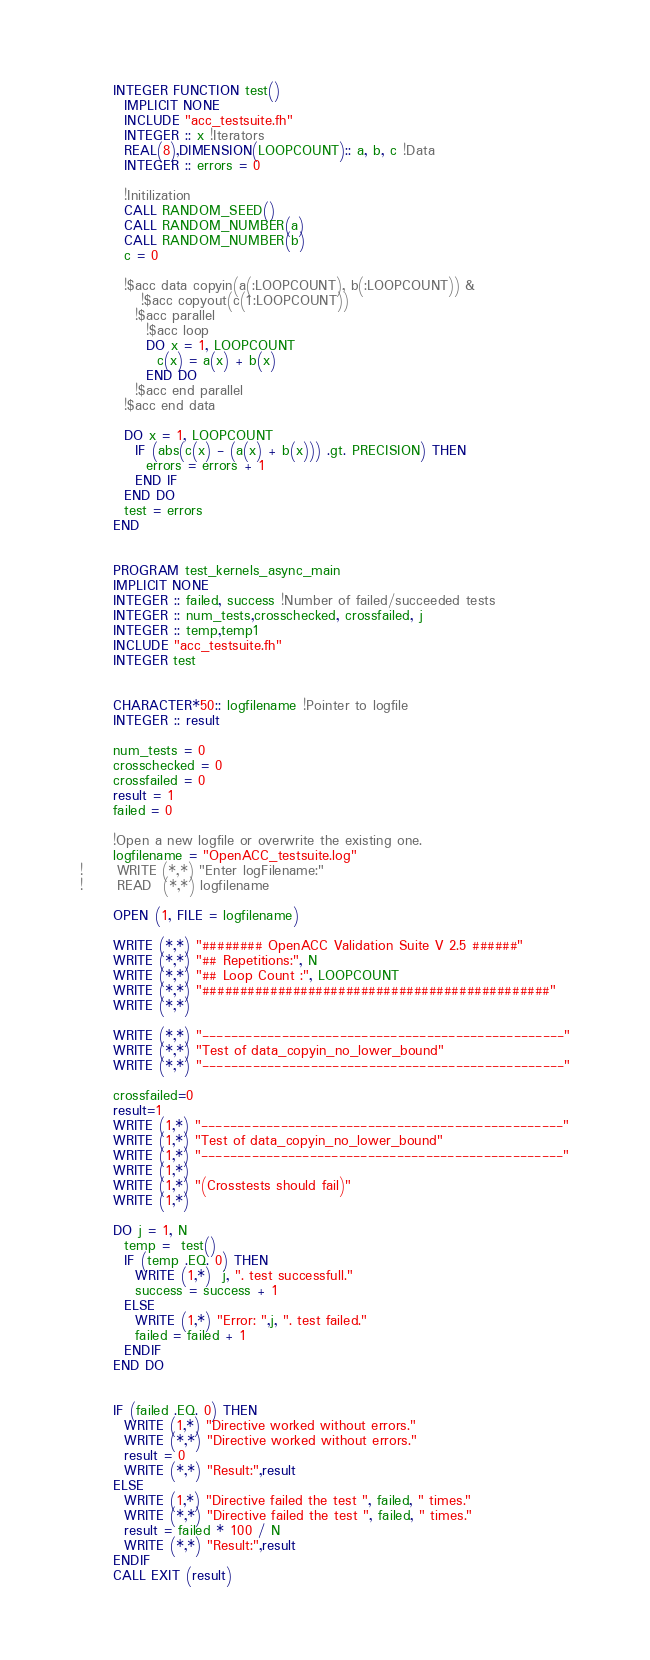Convert code to text. <code><loc_0><loc_0><loc_500><loc_500><_FORTRAN_>      INTEGER FUNCTION test()
        IMPLICIT NONE
        INCLUDE "acc_testsuite.fh"
        INTEGER :: x !Iterators
        REAL(8),DIMENSION(LOOPCOUNT):: a, b, c !Data
        INTEGER :: errors = 0

        !Initilization
        CALL RANDOM_SEED()
        CALL RANDOM_NUMBER(a)
        CALL RANDOM_NUMBER(b)
        c = 0

        !$acc data copyin(a(:LOOPCOUNT), b(:LOOPCOUNT)) &
           !$acc copyout(c(1:LOOPCOUNT))
          !$acc parallel
            !$acc loop
            DO x = 1, LOOPCOUNT
              c(x) = a(x) + b(x)
            END DO
          !$acc end parallel
        !$acc end data

        DO x = 1, LOOPCOUNT
          IF (abs(c(x) - (a(x) + b(x))) .gt. PRECISION) THEN
            errors = errors + 1
          END IF
        END DO
        test = errors
      END


      PROGRAM test_kernels_async_main
      IMPLICIT NONE
      INTEGER :: failed, success !Number of failed/succeeded tests
      INTEGER :: num_tests,crosschecked, crossfailed, j
      INTEGER :: temp,temp1
      INCLUDE "acc_testsuite.fh"
      INTEGER test


      CHARACTER*50:: logfilename !Pointer to logfile
      INTEGER :: result

      num_tests = 0
      crosschecked = 0
      crossfailed = 0
      result = 1
      failed = 0

      !Open a new logfile or overwrite the existing one.
      logfilename = "OpenACC_testsuite.log"
!      WRITE (*,*) "Enter logFilename:"
!      READ  (*,*) logfilename

      OPEN (1, FILE = logfilename)

      WRITE (*,*) "######## OpenACC Validation Suite V 2.5 ######"
      WRITE (*,*) "## Repetitions:", N
      WRITE (*,*) "## Loop Count :", LOOPCOUNT
      WRITE (*,*) "##############################################"
      WRITE (*,*)

      WRITE (*,*) "--------------------------------------------------"
      WRITE (*,*) "Test of data_copyin_no_lower_bound"
      WRITE (*,*) "--------------------------------------------------"

      crossfailed=0
      result=1
      WRITE (1,*) "--------------------------------------------------"
      WRITE (1,*) "Test of data_copyin_no_lower_bound"
      WRITE (1,*) "--------------------------------------------------"
      WRITE (1,*)
      WRITE (1,*) "(Crosstests should fail)"
      WRITE (1,*)

      DO j = 1, N
        temp =  test()
        IF (temp .EQ. 0) THEN
          WRITE (1,*)  j, ". test successfull."
          success = success + 1
        ELSE
          WRITE (1,*) "Error: ",j, ". test failed."
          failed = failed + 1
        ENDIF
      END DO


      IF (failed .EQ. 0) THEN
        WRITE (1,*) "Directive worked without errors."
        WRITE (*,*) "Directive worked without errors."
        result = 0
        WRITE (*,*) "Result:",result
      ELSE
        WRITE (1,*) "Directive failed the test ", failed, " times."
        WRITE (*,*) "Directive failed the test ", failed, " times."
        result = failed * 100 / N
        WRITE (*,*) "Result:",result
      ENDIF
      CALL EXIT (result)</code> 